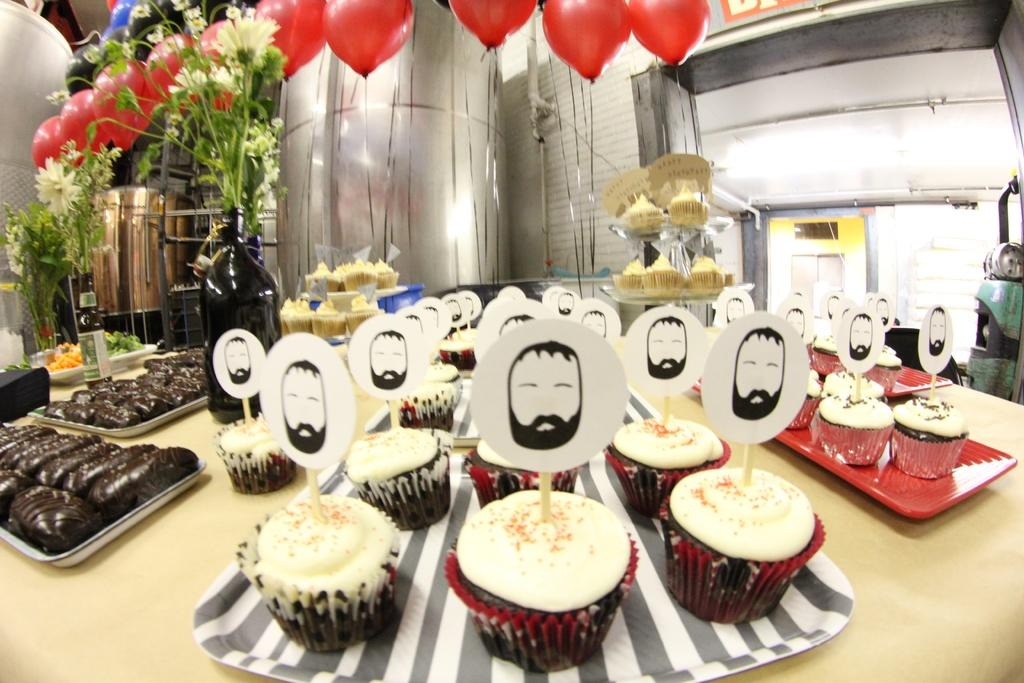What type of furniture is present in the image? There is a table in the image. What type of food is on the table? There are cupcakes on the table. How are the cupcakes arranged on the table? The cupcakes are in a tray. What other decorative items are on the table? There are flower vases and balloons on the table. What type of skin can be seen on the cupcakes in the image? There is no skin visible on the cupcakes in the image; they are baked goods. 